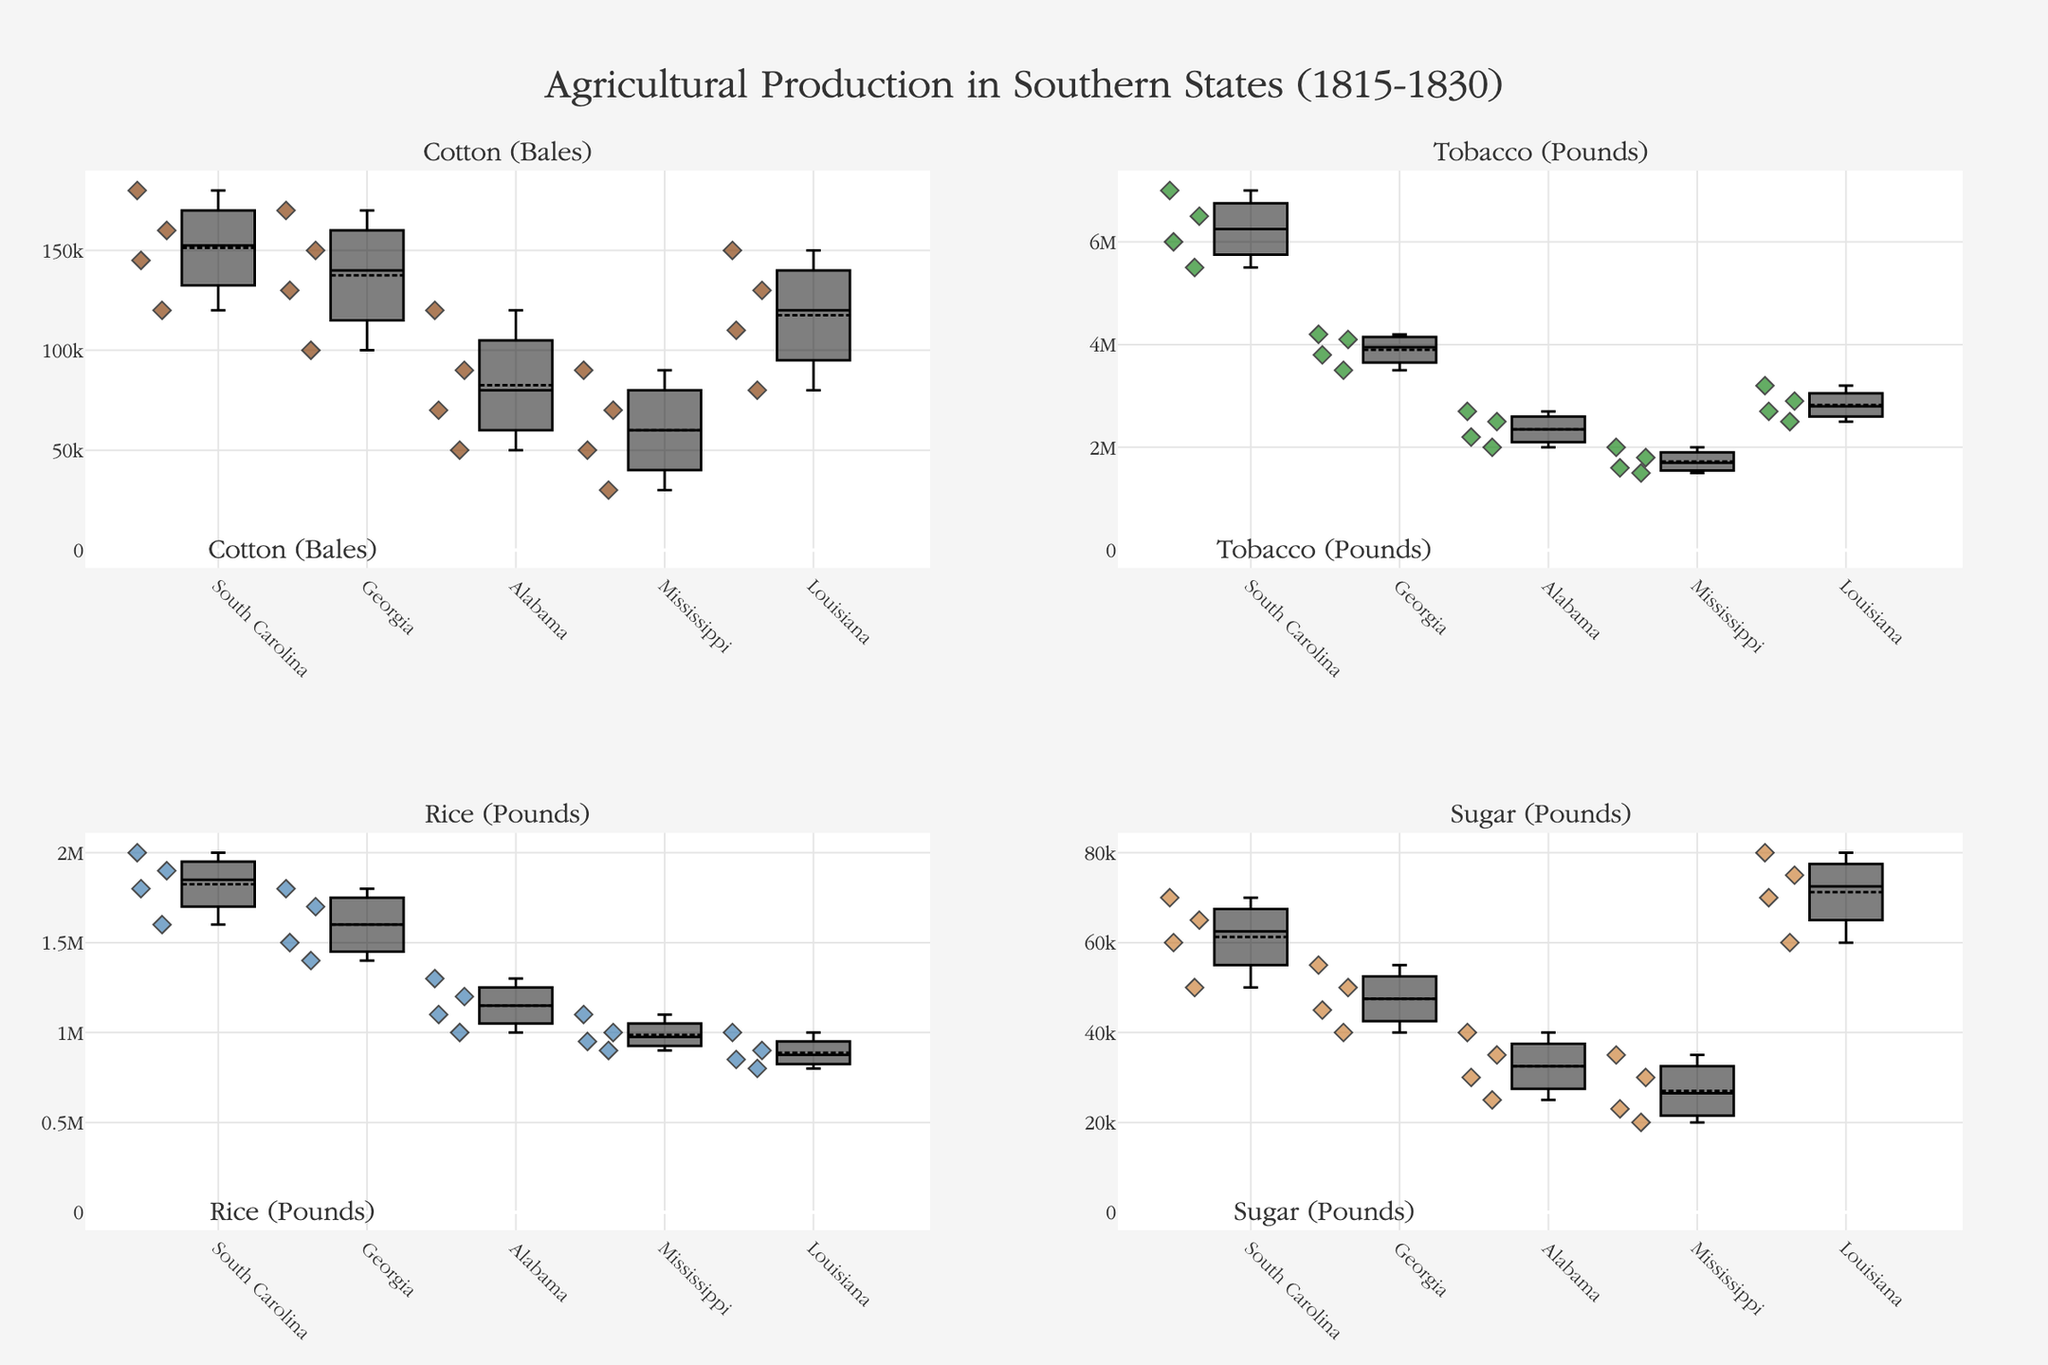What is the title of the figure? The title of a figure is usually placed at the top center of the plot and is meant to succinctly describe what the plot represents. The title can help viewers quickly understand the general theme of the figure.
Answer: Agricultural Production in Southern States (1815-1830) Which crop's production information is represented in the top-left subplot? The top-left subplot typically corresponds to the first crop listed in the code provided. By checking which crop is first mentioned, we can infer its position in the figure.
Answer: Cotton (Bales) How does the median cotton production in Louisiana compare to Alabama? To compare medians, observe the horizontal line inside each boxplot, which represents the median value. Compare the median lines for Louisiana and Alabama in the Cotton (Bales) subplot.
Answer: Louisiana's median cotton production is higher than Alabama's What is the color used to represent the data points in the Tobacco subplot? Each subplot uses a specific color for its data points, as defined in the code. By identifying the color designated for the Tobacco subplot, we can determine this detail.
Answer: Green Which state shows the highest variability in rice production? Variability in a box plot is indicated by the length of the box and the whiskers. The larger the spread, the higher the variability. Analyze the Rice subplot and compare the variability among the states.
Answer: South Carolina Is the average production of sugar in Georgia higher than in Alabama? First, identify the sugar production values for both states. Then calculate the mean production for Georgia and compare it with Alabama. Summarize the result.
Answer: Yes Which state experienced the most consistent tobacco production over the years? The most consistent production is marked by the smallest interquartile range (IQR) and the shortest whiskers in the box plot. Compare the Tobacco subplot for each state to determine this.
Answer: Alabama In which year did South Carolina produce the maximum rice? To determine the specific year of peak production, identify the highest point among the South Carolina data points within the Rice subplot. Extract the corresponding year.
Answer: 1830 What trend do you notice in cotton production for Mississippi from 1815 to 1830? Identify the position of data points for Mississippi in the Cotton (Bales) subplot and observe their changes across the years. Describe the noticeable pattern in production.
Answer: Increasing trend 